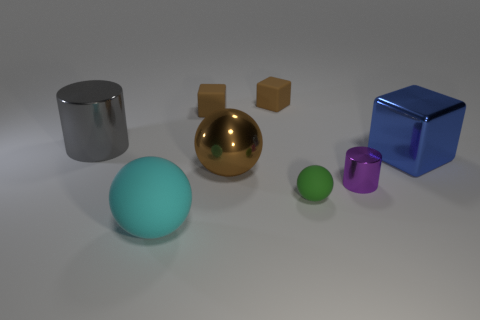Add 1 blue shiny cubes. How many objects exist? 9 Subtract all cubes. How many objects are left? 5 Subtract 1 green spheres. How many objects are left? 7 Subtract all blue objects. Subtract all large cyan spheres. How many objects are left? 6 Add 6 blue cubes. How many blue cubes are left? 7 Add 7 tiny gray things. How many tiny gray things exist? 7 